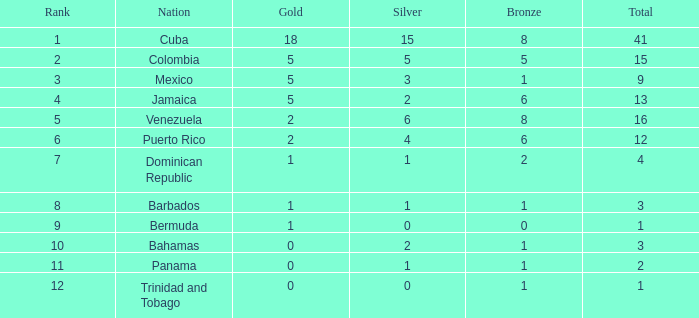Which total is the minimum one with a rank smaller than 2 and a silver lesser than 15? None. 